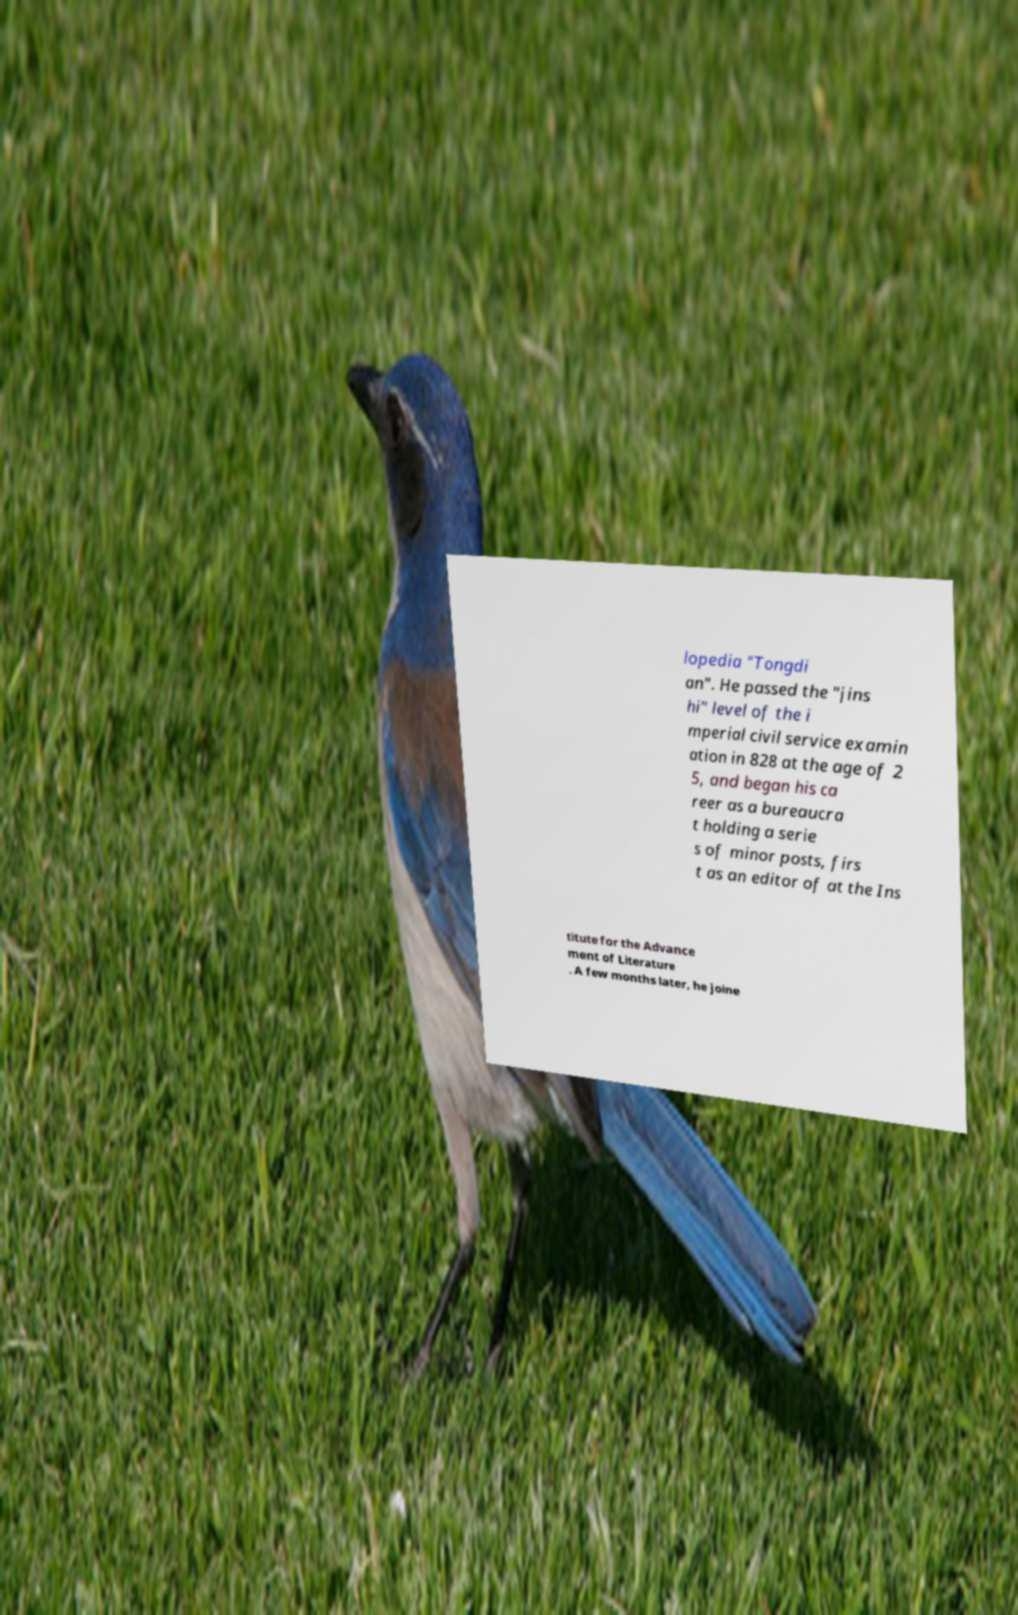Please identify and transcribe the text found in this image. lopedia "Tongdi an". He passed the "jins hi" level of the i mperial civil service examin ation in 828 at the age of 2 5, and began his ca reer as a bureaucra t holding a serie s of minor posts, firs t as an editor of at the Ins titute for the Advance ment of Literature . A few months later, he joine 